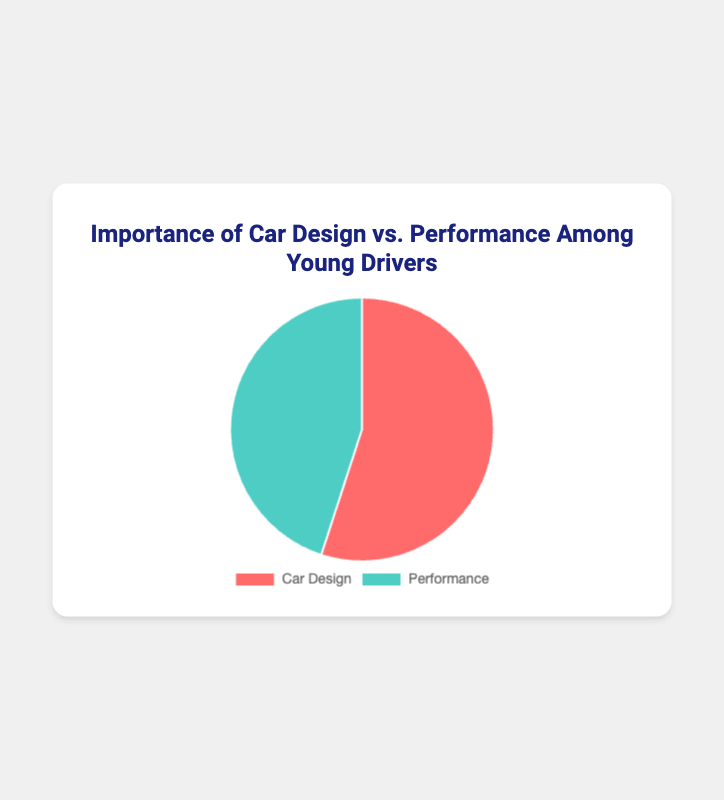What are the two categories represented in the pie chart? The pie chart represents two categories: "Car Design" and "Performance." These are the aspects of cars that young drivers consider important.
Answer: Car Design and Performance Which category is considered more important by young drivers, Car Design or Performance? Referring to the figure, we see that the "Car Design" category has a larger portion of the pie chart compared to "Performance."
Answer: Car Design What is the percentage difference between the importance of Car Design and Performance? The "Car Design" category accounts for 55%, and the "Performance" category accounts for 45%. The difference is calculated by subtracting the smaller percentage from the larger one: 55% - 45% = 10%.
Answer: 10% How do the colors in the pie chart help differentiate between Car Design and Performance? The pie chart uses different colors to represent each category: "Car Design" is shown in red, and "Performance" is shown in green. This visual distinction helps easily differentiate between the two categories.
Answer: Red and Green If the total number of surveyed young drivers is 200, how many of them think Car Design is more important than Performance? 55% of 200 young drivers consider Car Design more important. The number can be calculated as (55/100) * 200 = 110.
Answer: 110 What percentage of young drivers consider Performance to be less important than Car Design? As "Car Design" is more important for 55% of the respondents, it implies that 100% - 55% = 45% consider "Performance" to be less important.
Answer: 45% What is the combined percentage of young drivers who value either Car Design or Performance highly? Both categories combined account for 55% + 45% = 100%. Since no other categories are mentioned, this means all surveyed young drivers value either Car Design or Performance.
Answer: 100% Which category has a higher percentage, and by how much? "Car Design" has a higher percentage (55%) compared to "Performance" (45%). The difference is calculated as 55% - 45% = 10%.
Answer: Car Design by 10% 